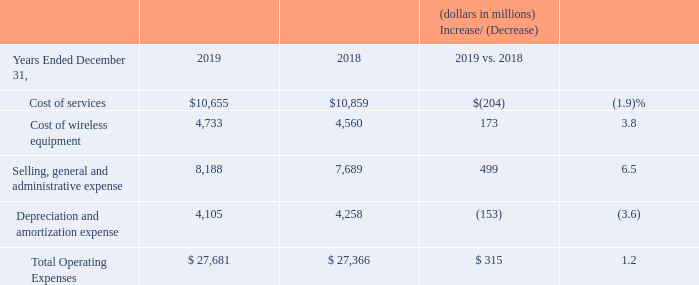Cost of Services Cost of services decreased $204 million, or 1.9%, during 2019 compared to 2018, primarily due to lower access costs resulting from a decline in voice connections, as well as lower employee-related costs associated with the lower headcount resulting from the Voluntary Separation Program, offset by an increase in regulatory fees.
Cost of Wireless Equipment Cost of wireless equipment increased $173 million, or 3.8%, during 2019 compared to 2018, primarily driven by a shift to higher priced units in the mix of wireless devices sold and an increase in the number of wireless devices sold.
Selling, General and Administrative Expense Selling, general and administrative expense increased $499 million, or 6.5%, during 2019 compared to 2018, due to increases in advertising expenses and sales commission expense, which were partially offset by decreases in employee-related costs resulting from the Voluntary Separation Program. The increase in sales commission expense was primarily due to a lower net deferral of commission costs in 2019 as compared to 2018 as a result of the adoption of Topic 606 on January 1, 2018 using a modified retrospective approach.
Depreciation and Amortization Expense Depreciation and amortization expense decreased $153 million, or 3.6%, during 2019 compared to 2018, driven by the change in the mix of total Verizon depreciable assets and Business’s usage of those assets.
How much was the Cost of services in 2019?
Answer scale should be: million. $10,655. How much was the Cost of Wireless Equipment in 2019?
Answer scale should be: million. 4,733. How much was the Selling, General and Administrative Expense in 2019?
Answer scale should be: million. 8,188. What is the change in Cost of services from 2018 to 2019?
Answer scale should be: million. 10,655-10,859
Answer: -204. What is the change in Cost of wireless equipment from 2018 to 2019?
Answer scale should be: million. 4,733-4,560
Answer: 173. What is the change in Selling, general and administrative expense from 2018 to 2019?
Answer scale should be: million. 8,188-7,689
Answer: 499. 